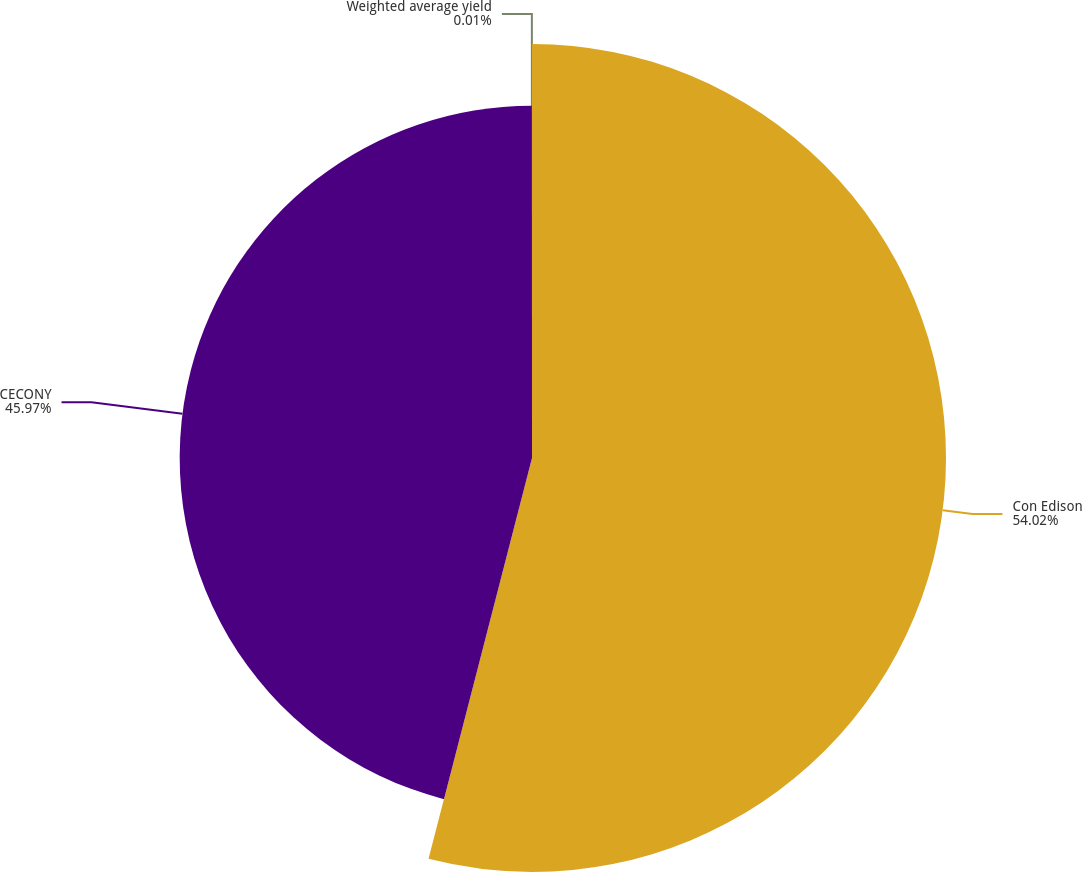Convert chart to OTSL. <chart><loc_0><loc_0><loc_500><loc_500><pie_chart><fcel>Con Edison<fcel>CECONY<fcel>Weighted average yield<nl><fcel>54.02%<fcel>45.97%<fcel>0.01%<nl></chart> 